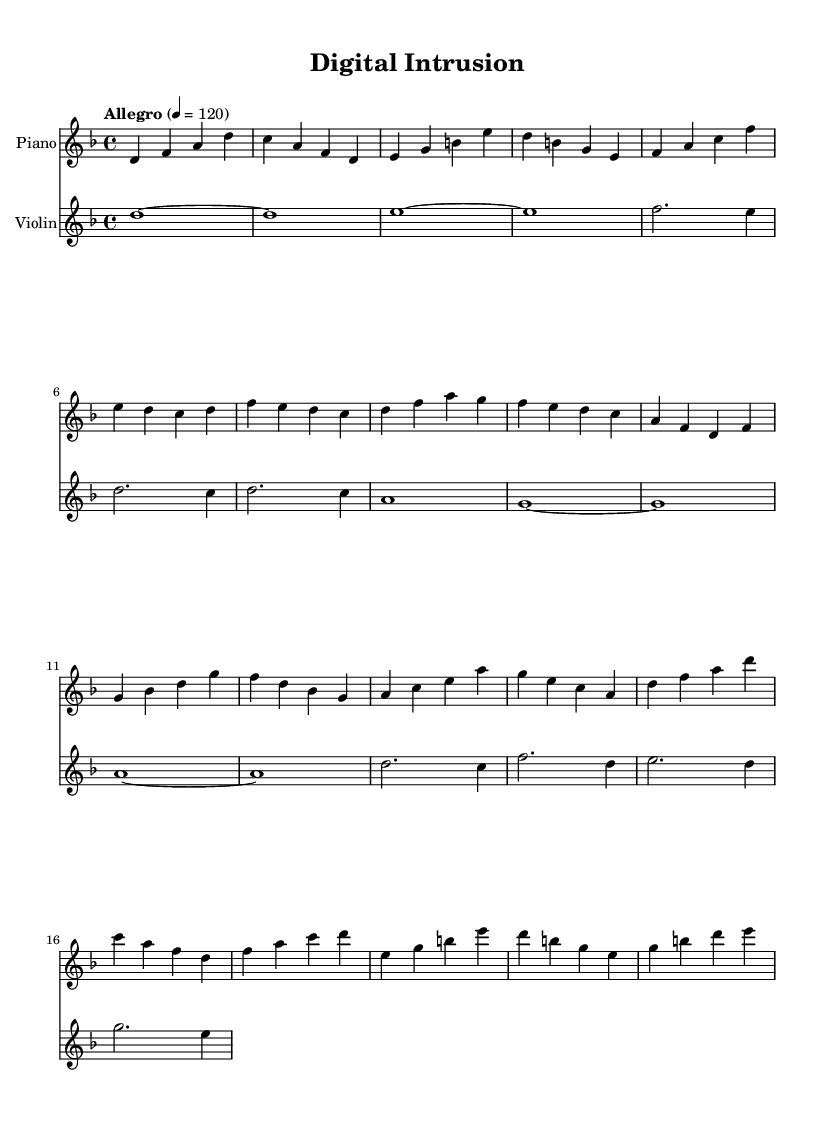What is the key signature of this music? The key signature is indicated by the two flats in the key signature section at the beginning of the music. This corresponds to the key of D minor.
Answer: D minor What is the time signature of this music? The time signature is represented in the upper left corner above the staff as 4/4, indicating four beats in each measure and a quarter note receives one beat.
Answer: 4/4 What is the tempo marking for this score? The tempo is indicated with the word "Allegro" at the beginning of the score, which typically means a fast tempo, specifically at a metronome marking of 120 beats per minute.
Answer: Allegro How many measures are there for the piano part? By counting the number of vertical lines (bar lines) in the piano staff, we find there are 14 measures in total, as the last bar line is included in the count.
Answer: 14 Which instrument has the longest note value? When observing the notations, the violin part has a whole note (which gets a whole measure in 4/4 time) represented as 'd1~' at the beginning of the score, which is the longest note value present.
Answer: Violin What is the highest pitch note in the sheet music? The highest pitch in the provided score is 'g' in the violin part, which appears towards the end of the music. This can be identified by visual inspection of the notes.
Answer: g Which instrument plays a repeated motif throughout the score? The piano part plays several repeated patterns or motifs, particularly evident in its rhythmic and melodic figures returning multiple times in the measures.
Answer: Piano 